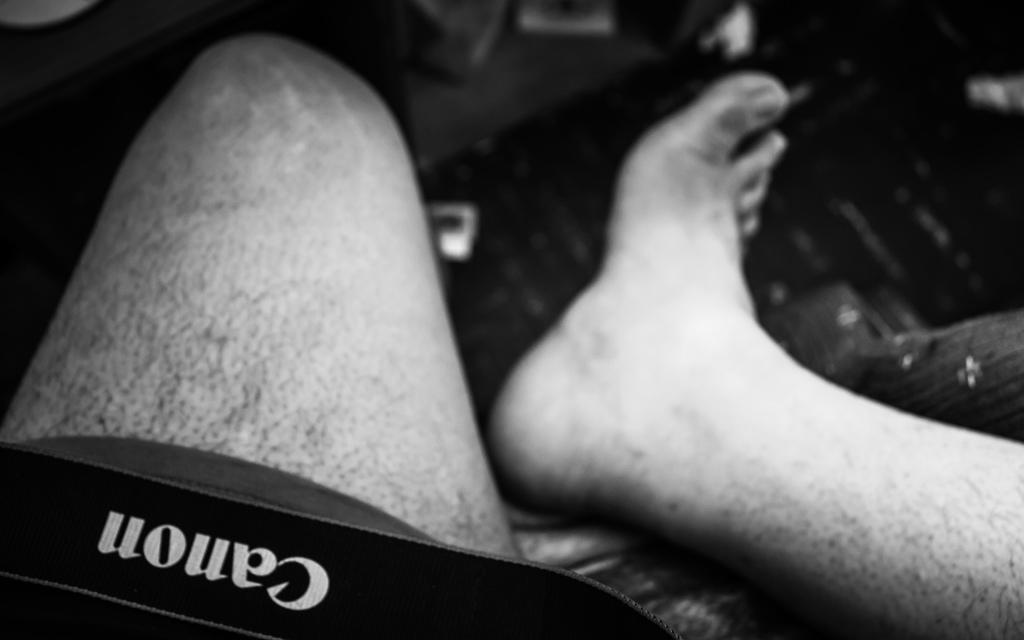How would you summarize this image in a sentence or two? In the image there are persons legs. To the bottom left of the image there is a black object with cannon on it. 